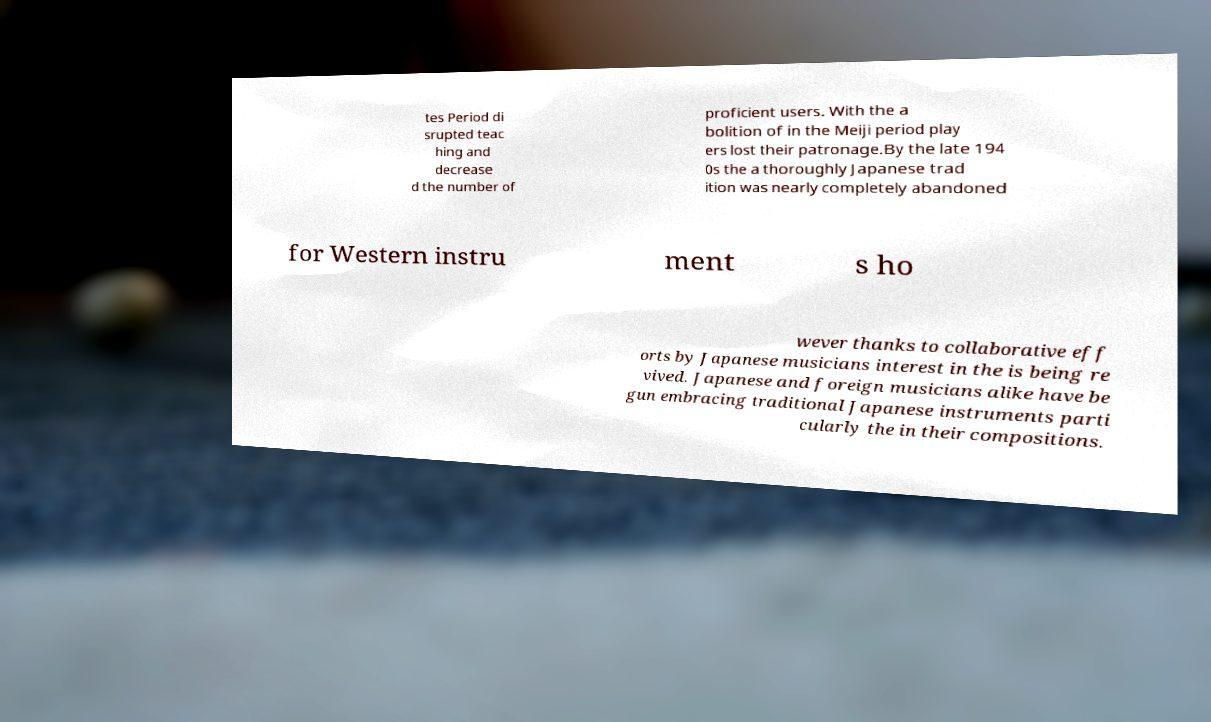I need the written content from this picture converted into text. Can you do that? tes Period di srupted teac hing and decrease d the number of proficient users. With the a bolition of in the Meiji period play ers lost their patronage.By the late 194 0s the a thoroughly Japanese trad ition was nearly completely abandoned for Western instru ment s ho wever thanks to collaborative eff orts by Japanese musicians interest in the is being re vived. Japanese and foreign musicians alike have be gun embracing traditional Japanese instruments parti cularly the in their compositions. 